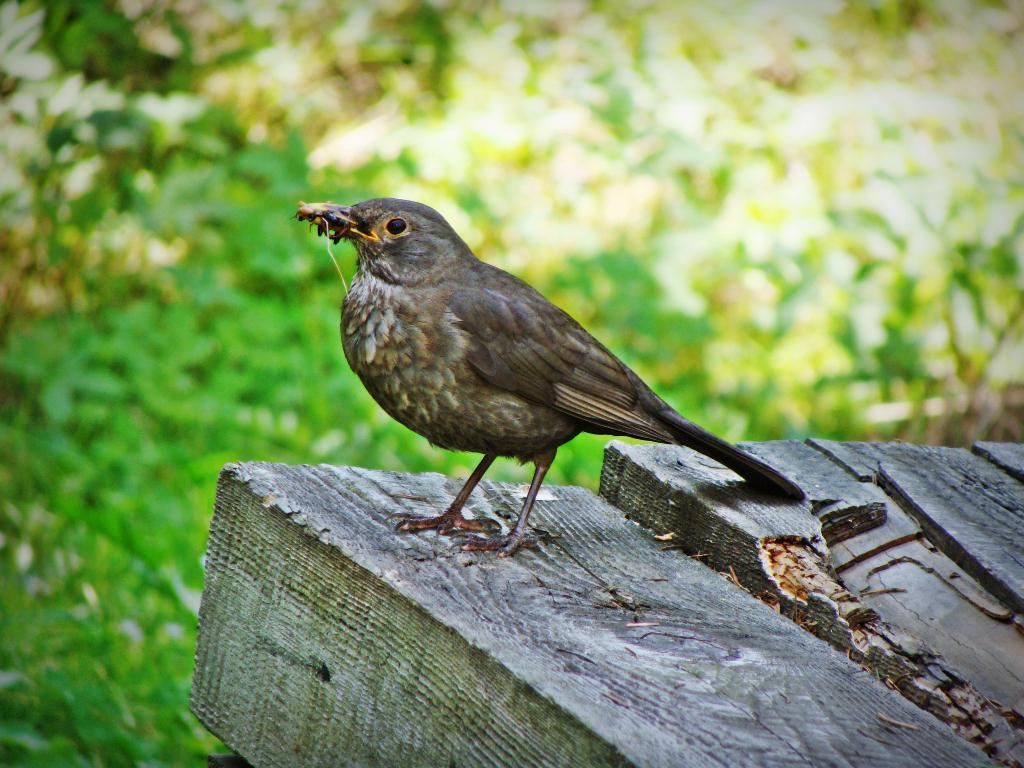Could you give a brief overview of what you see in this image? In this picture there is a bird holding an insect and standing on the wood. At the back there are trees. 